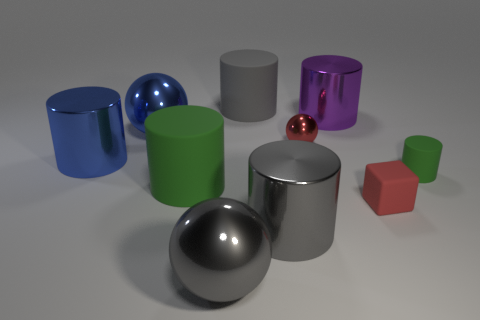Subtract all big balls. How many balls are left? 1 Subtract all purple cylinders. How many cylinders are left? 5 Subtract 1 cylinders. How many cylinders are left? 5 Subtract all blue cylinders. Subtract all gray spheres. How many cylinders are left? 5 Add 4 green cylinders. How many green cylinders are left? 6 Add 4 green rubber cylinders. How many green rubber cylinders exist? 6 Subtract 0 brown blocks. How many objects are left? 10 Subtract all spheres. How many objects are left? 7 Subtract all purple things. Subtract all large red shiny spheres. How many objects are left? 9 